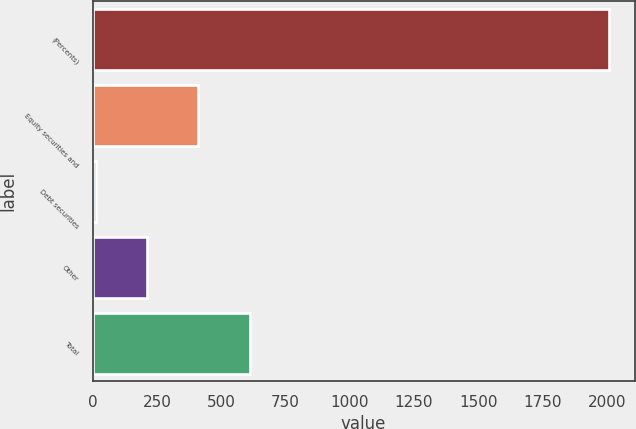Convert chart to OTSL. <chart><loc_0><loc_0><loc_500><loc_500><bar_chart><fcel>(Percents)<fcel>Equity securities and<fcel>Debt securities<fcel>Other<fcel>Total<nl><fcel>2008<fcel>411.2<fcel>12<fcel>211.6<fcel>610.8<nl></chart> 